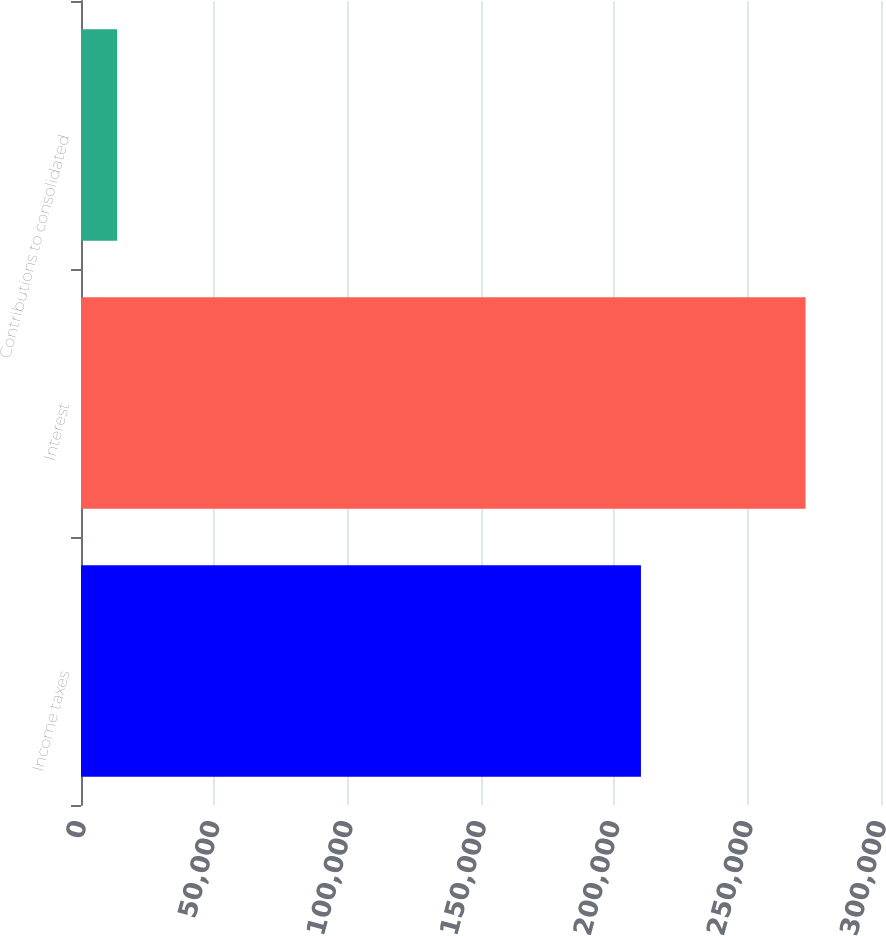<chart> <loc_0><loc_0><loc_500><loc_500><bar_chart><fcel>Income taxes<fcel>Interest<fcel>Contributions to consolidated<nl><fcel>209982<fcel>271711<fcel>13568<nl></chart> 